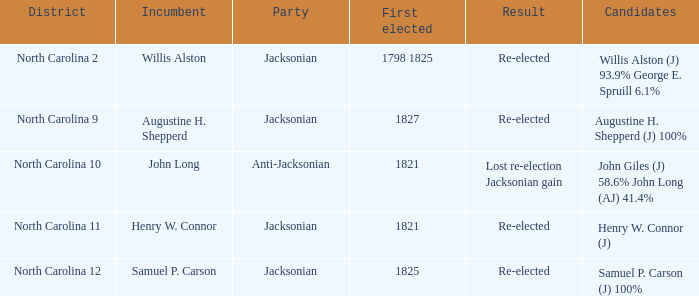Name the result for willis alston Re-elected. 